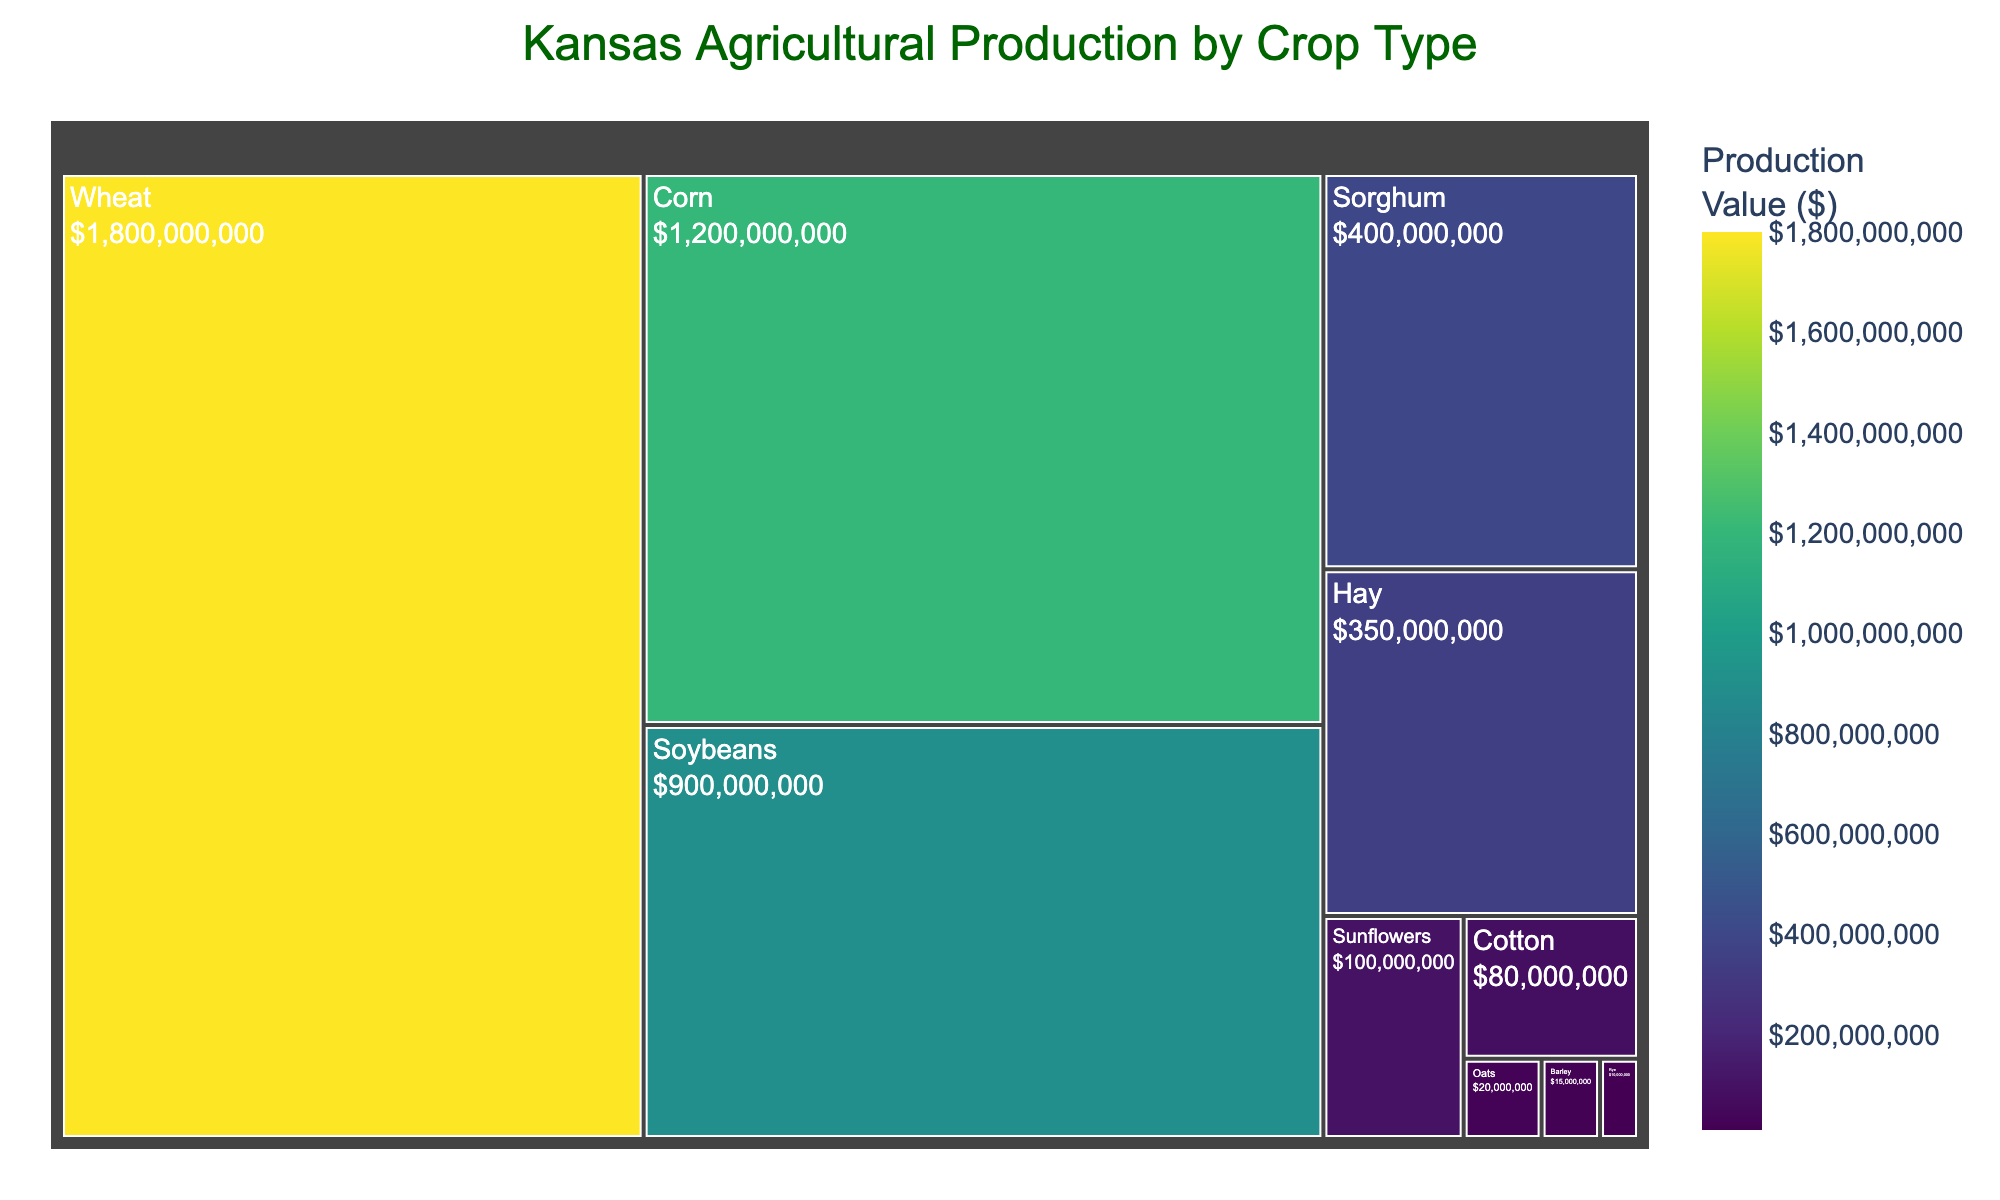What's the title of the treemap? The title of the treemap is positioned at the top center of the plot. It describes the main topic of the visualization which is shown in prominent text.
Answer: Kansas Agricultural Production by Crop Type How many crop types are displayed? The treemap visually divides areas labeled with different crop types. Count the distinct labels to determine the number of crop types shown.
Answer: 10 Which crop has the highest production value? Examine the treemap for the largest portion and the corresponding label. The size is proportional to the production value, so the biggest section represents the crop with the highest value.
Answer: Wheat What is the total production value of Soybeans and Sorghum combined? Identify the production values for Soybeans and Sorghum from the labels on the treemap. Add these values together: $900,000,000 (Soybeans) + $400,000,000 (Sorghum).
Answer: $1,300,000,000 Which crop has a greater production value, Hay or Sunflowers? Look at the sizes and production values of the sections labeled "Hay" and "Sunflowers". Compare the numbers to see which is greater.
Answer: Hay Which crop types have a production value greater than $500,000,000? Identify the data points where the production value exceeds $500,000,000. These will have larger sizes on the treemap. The sections for these crops are larger and should be clearly labeled with values over $500,000,000.
Answer: Wheat, Corn, Soybeans What is the smallest production value displayed and which crop does it belong to? Find the smallest section on the treemap, read the label and the associated production value.
Answer: Rye, $10,000,000 Which two crops have the smallest difference in their production values? Scan for crops with close sizes and compare their production values. Calculate the differences and find the pair with the smallest difference.
Answer: Oats and Barley How does the production value of Corn compare to Cotton? Locate the sections labeled "Corn" and "Cotton" and compare their sizes and values. Corn's value is significantly higher than Cotton's.
Answer: Corn's production value is much higher than Cotton's What is the color theme used to represent the production values? Observe the colors used throughout the treemap. The continuous color scale represents numerical values, where different shades indicate different production values.
Answer: Viridis 